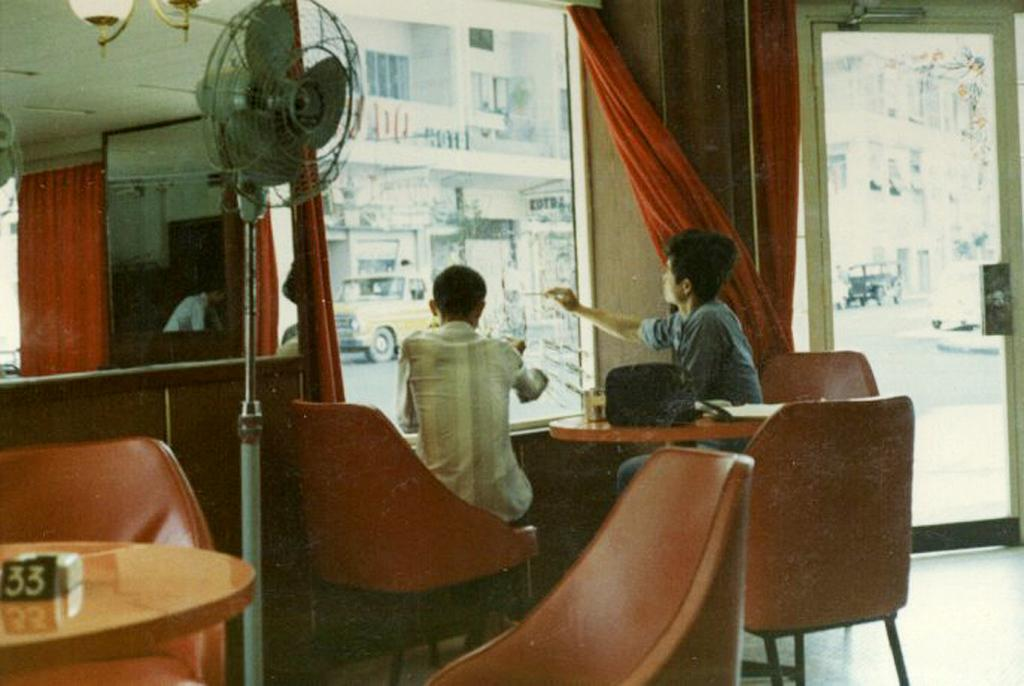How many people are sitting in chairs in the image? There are two people sitting in chairs in the image. What are the people doing in the image? The people are looking at the window. What can be seen in the image besides the people and chairs? There is a fan, a mirror, and a door in the image. What type of wristwatch is the doll wearing in the image? There is no doll or wristwatch present in the image. How many cherries are on the table in the image? There are no cherries present in the image. 